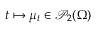Convert formula to latex. <formula><loc_0><loc_0><loc_500><loc_500>t \mapsto \mu _ { t } \in \ m a t h s c r { P } _ { 2 } ( \Omega )</formula> 